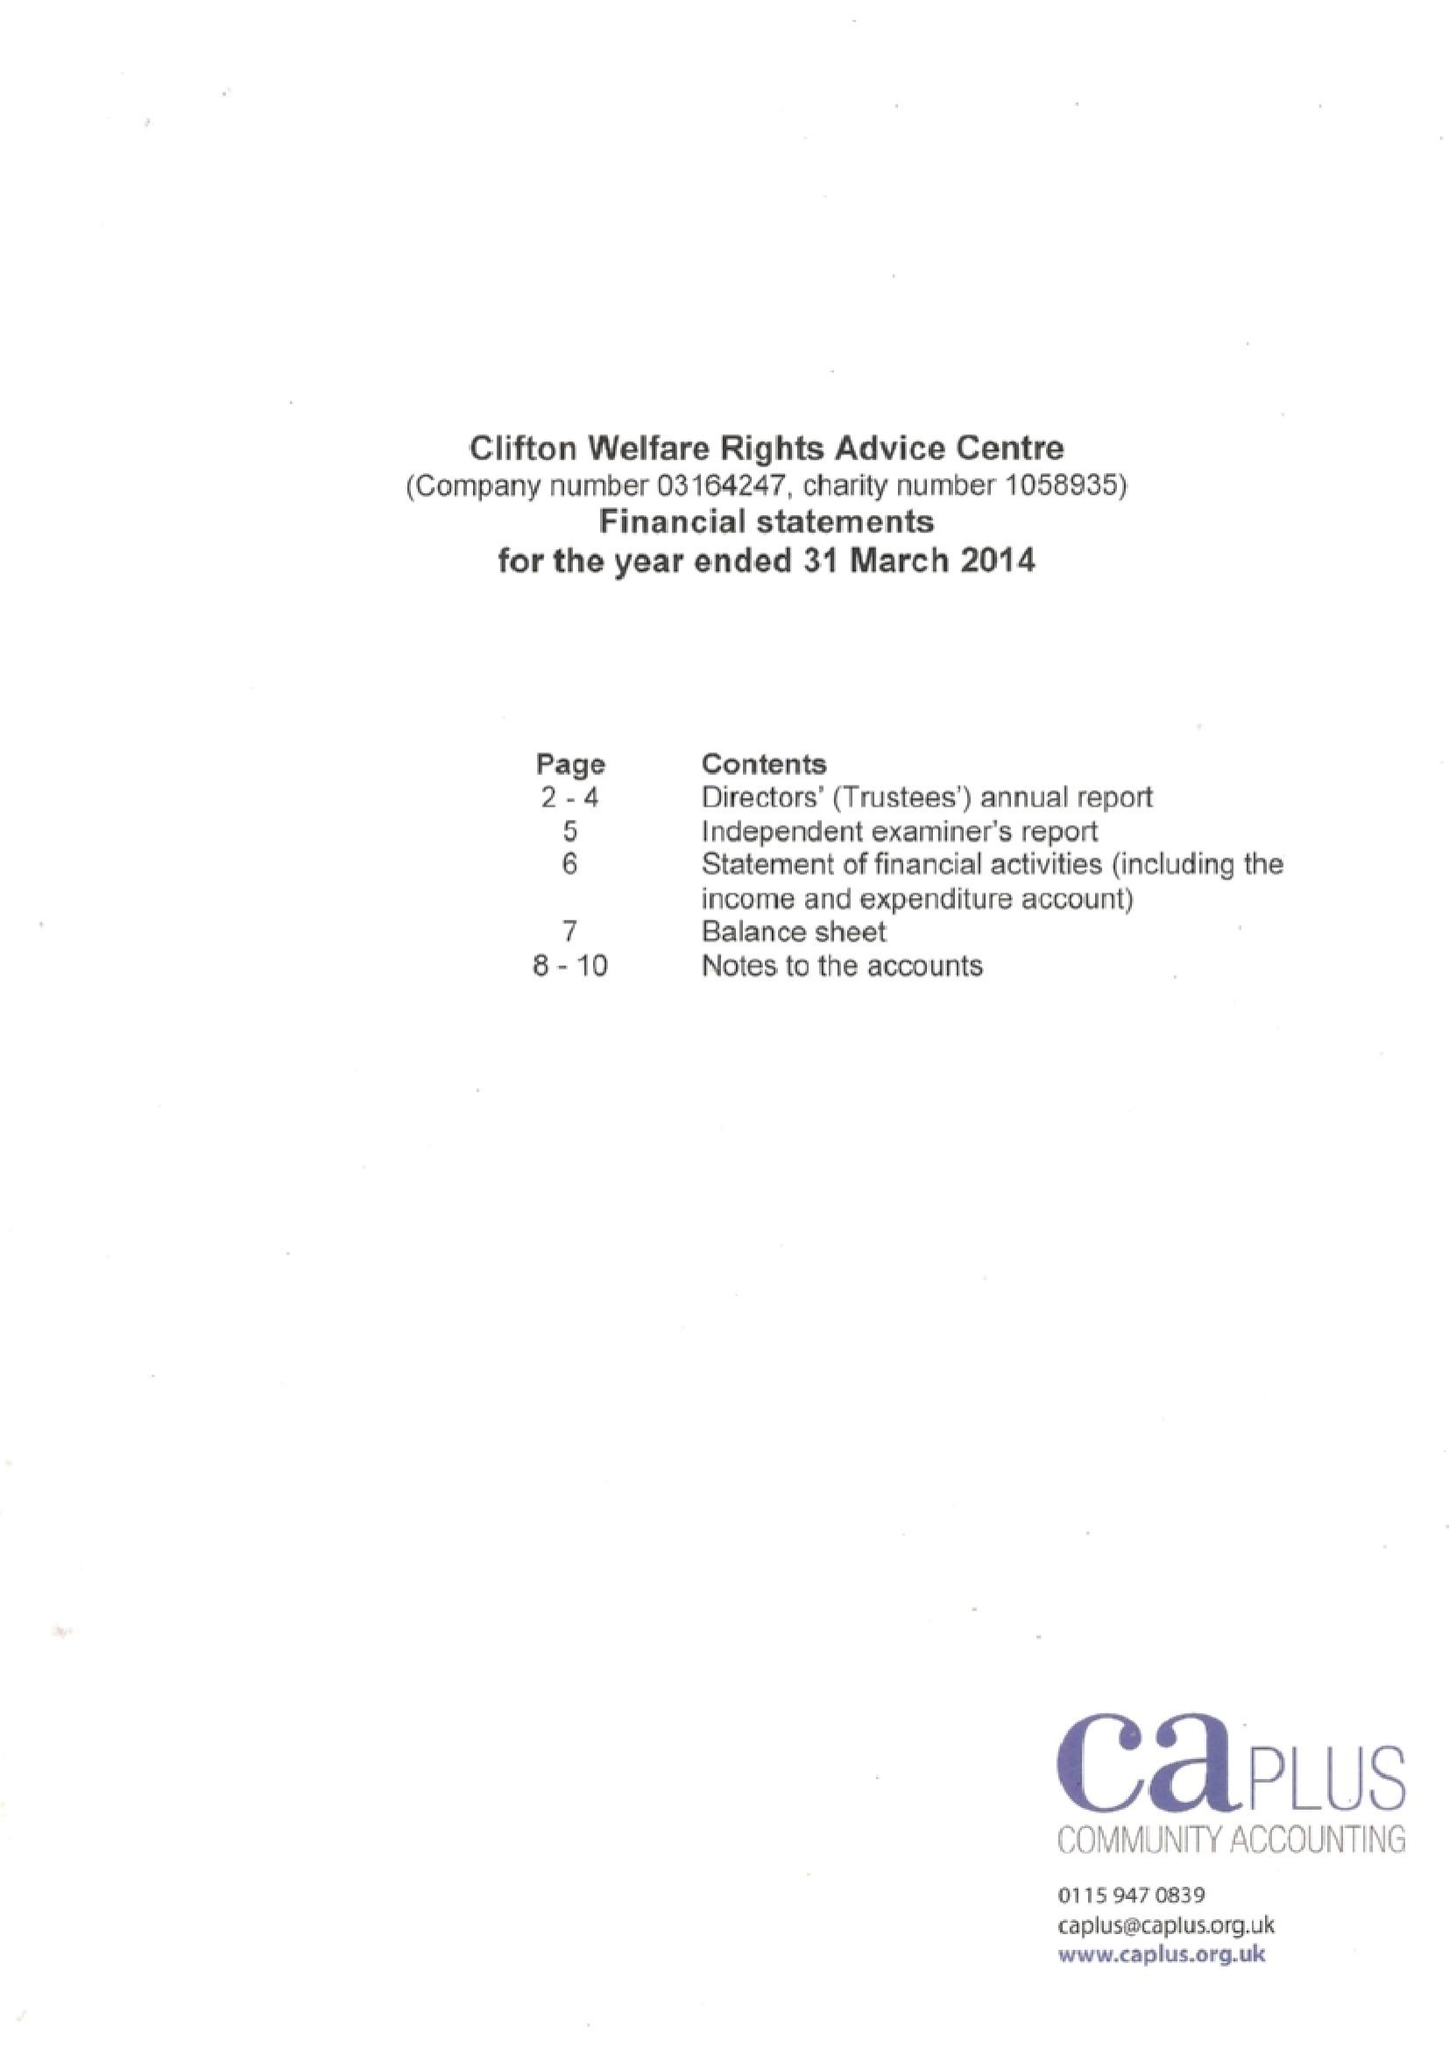What is the value for the address__street_line?
Answer the question using a single word or phrase. SOUTHCHURCH DRIVE 